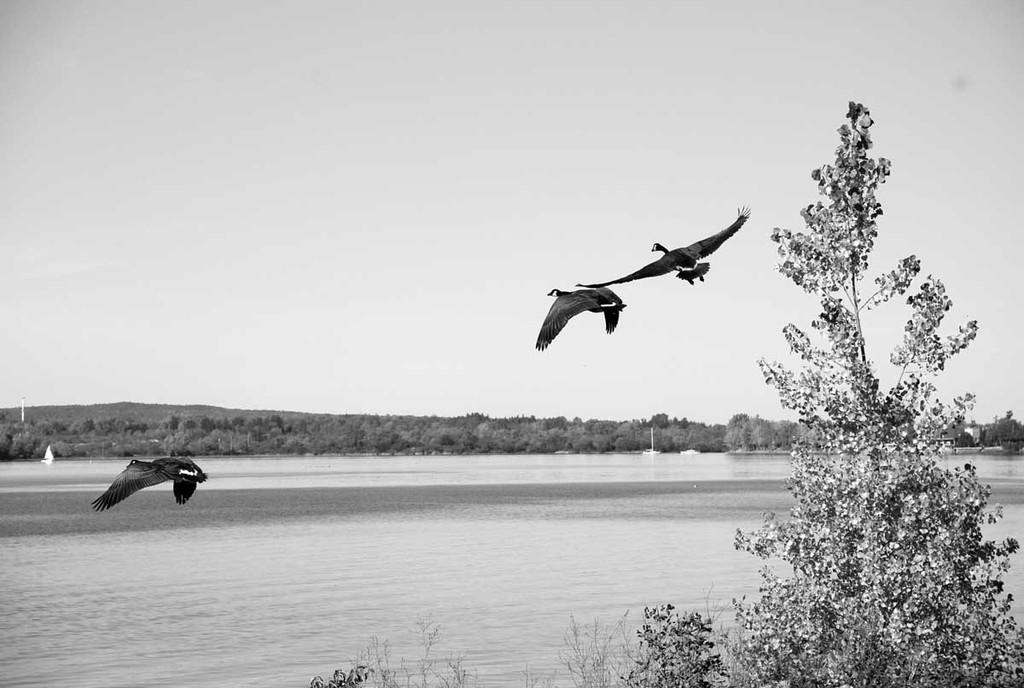What is present at the bottom of the image? There is water at the bottom of the image. What can be seen in the middle of the image? Three birds are flying in the middle of the image. What type of vegetation is visible at the back of the image? There are trees at the back of the image. What is visible at the top of the image? The sky is visible at the top of the image. What type of chalk is being used by the bears in the image? There are no bears or chalk present in the image. How does the scarf help the birds fly in the image? There are no scarves present in the image, and the birds are flying without any visible assistance. 